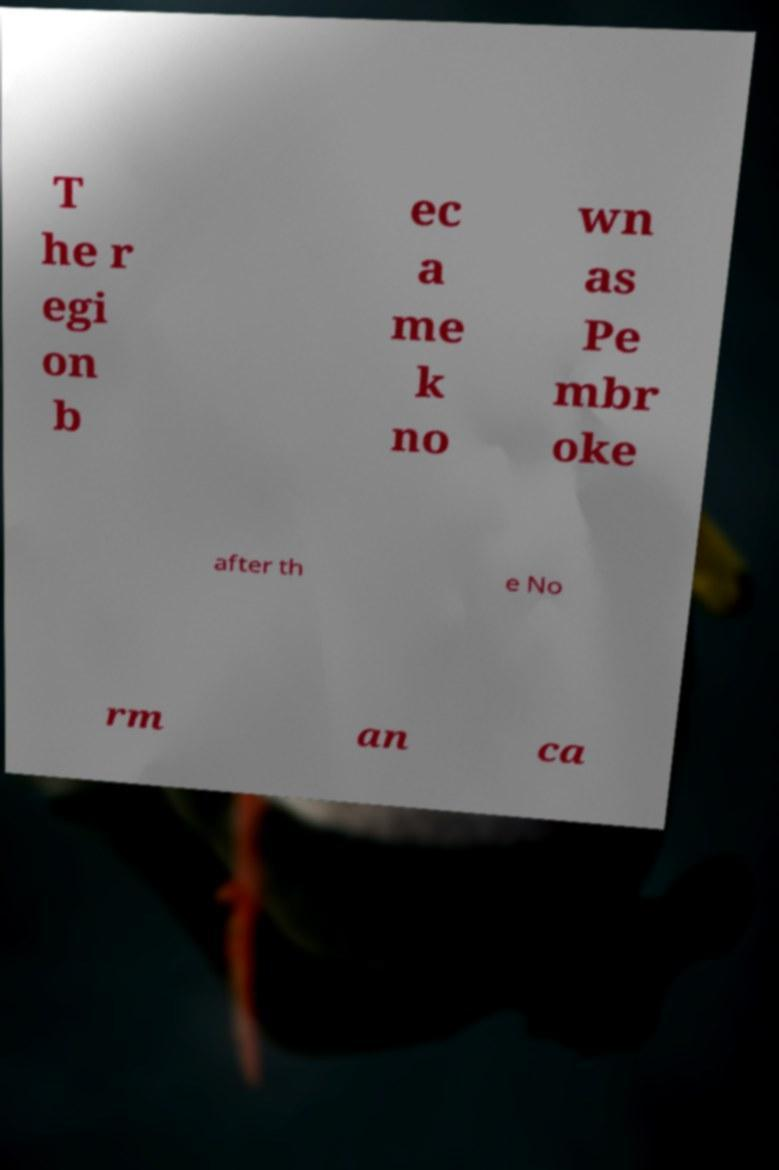Could you assist in decoding the text presented in this image and type it out clearly? T he r egi on b ec a me k no wn as Pe mbr oke after th e No rm an ca 